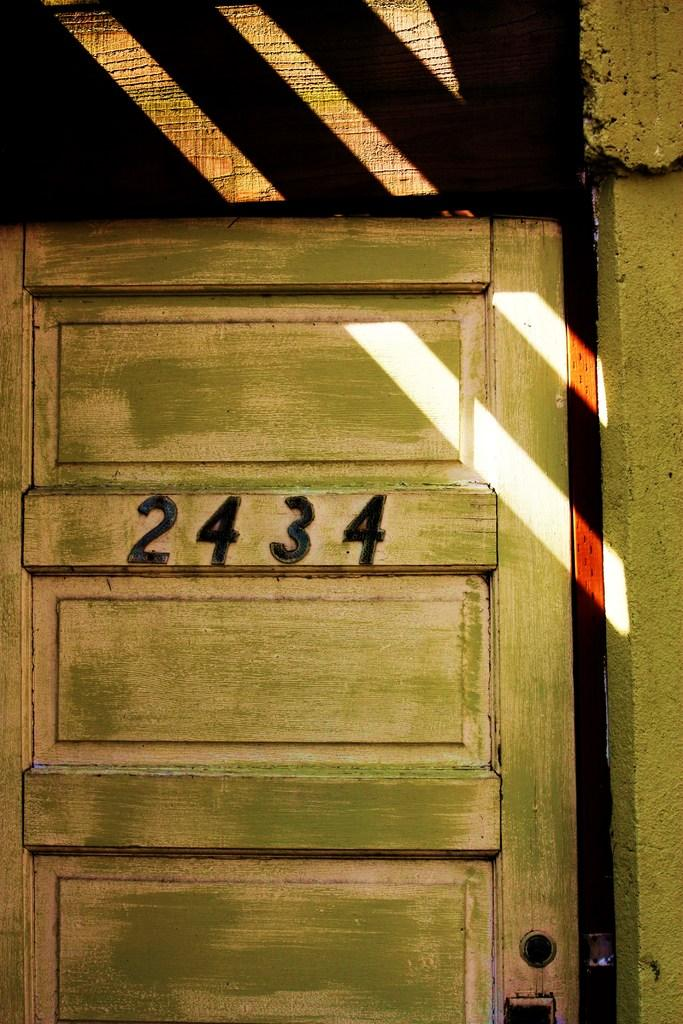What is a prominent feature in the image? There is a door in the image. What can be seen on the door? There are numbers on the door. Can you see the servant looking at the door in the image? There is no servant or any person visible in the image; it only shows a door with numbers. 